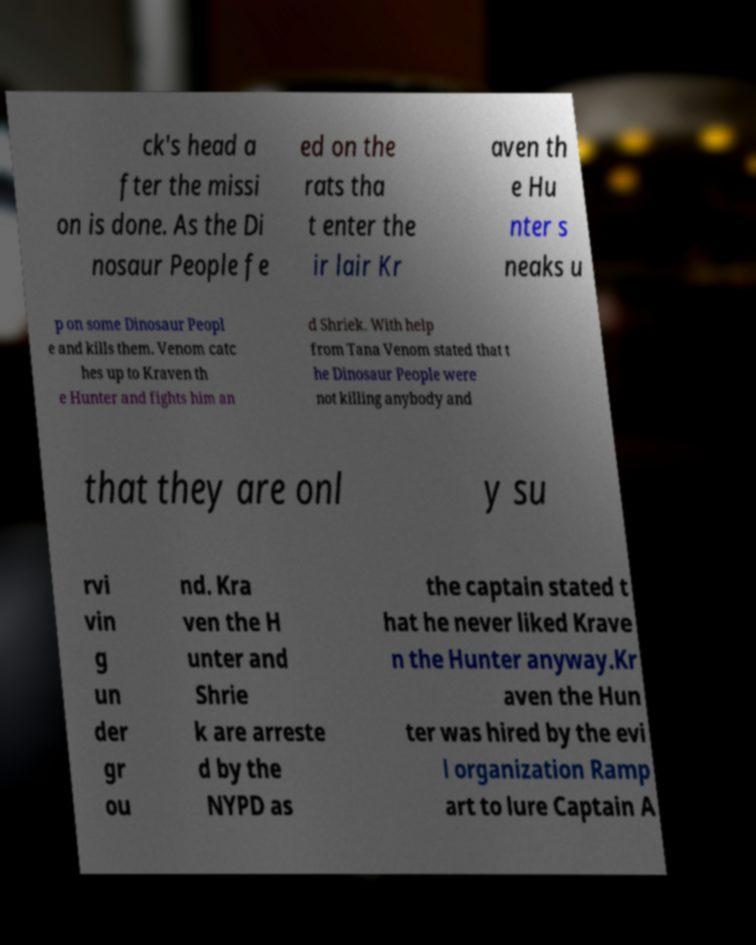Please read and relay the text visible in this image. What does it say? ck's head a fter the missi on is done. As the Di nosaur People fe ed on the rats tha t enter the ir lair Kr aven th e Hu nter s neaks u p on some Dinosaur Peopl e and kills them. Venom catc hes up to Kraven th e Hunter and fights him an d Shriek. With help from Tana Venom stated that t he Dinosaur People were not killing anybody and that they are onl y su rvi vin g un der gr ou nd. Kra ven the H unter and Shrie k are arreste d by the NYPD as the captain stated t hat he never liked Krave n the Hunter anyway.Kr aven the Hun ter was hired by the evi l organization Ramp art to lure Captain A 